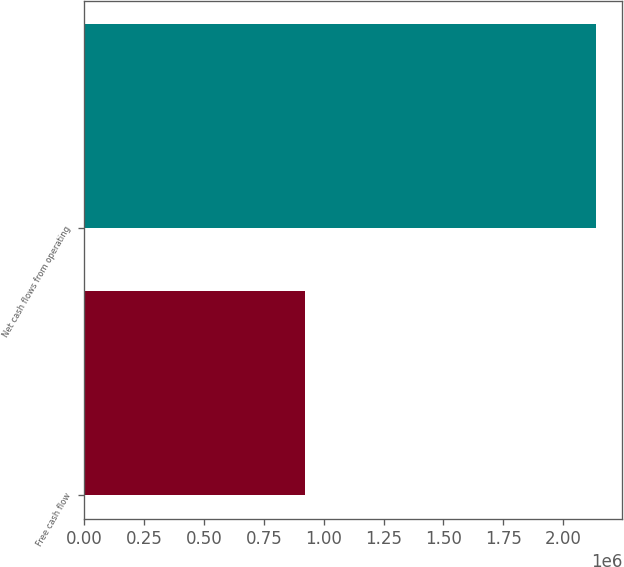<chart> <loc_0><loc_0><loc_500><loc_500><bar_chart><fcel>Free cash flow<fcel>Net cash flows from operating<nl><fcel>923670<fcel>2.1398e+06<nl></chart> 